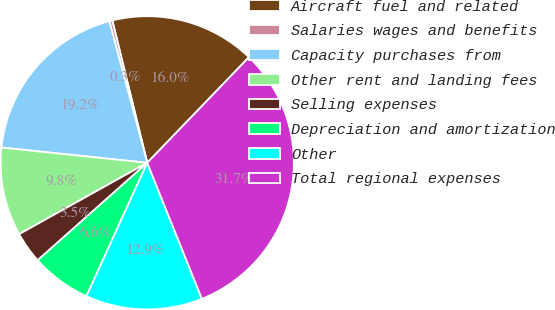Convert chart. <chart><loc_0><loc_0><loc_500><loc_500><pie_chart><fcel>Aircraft fuel and related<fcel>Salaries wages and benefits<fcel>Capacity purchases from<fcel>Other rent and landing fees<fcel>Selling expenses<fcel>Depreciation and amortization<fcel>Other<fcel>Total regional expenses<nl><fcel>16.03%<fcel>0.34%<fcel>19.17%<fcel>9.75%<fcel>3.48%<fcel>6.62%<fcel>12.89%<fcel>31.72%<nl></chart> 